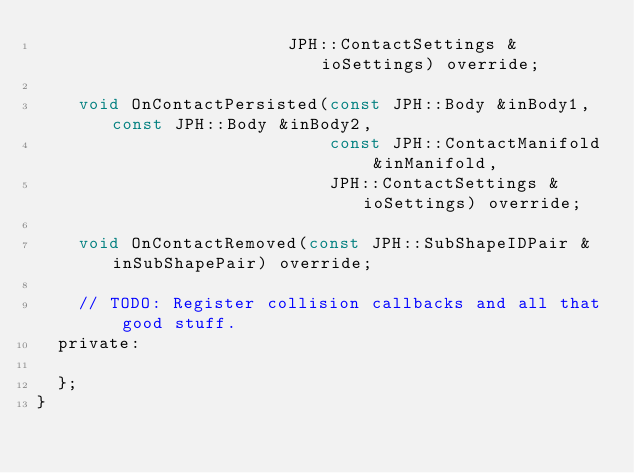<code> <loc_0><loc_0><loc_500><loc_500><_C_>						JPH::ContactSettings &ioSettings) override;

	void OnContactPersisted(const JPH::Body &inBody1, const JPH::Body &inBody2, 
							const JPH::ContactManifold &inManifold, 
							JPH::ContactSettings &ioSettings) override;

	void OnContactRemoved(const JPH::SubShapeIDPair &inSubShapePair) override;

	// TODO: Register collision callbacks and all that good stuff.
  private:

  };
}</code> 